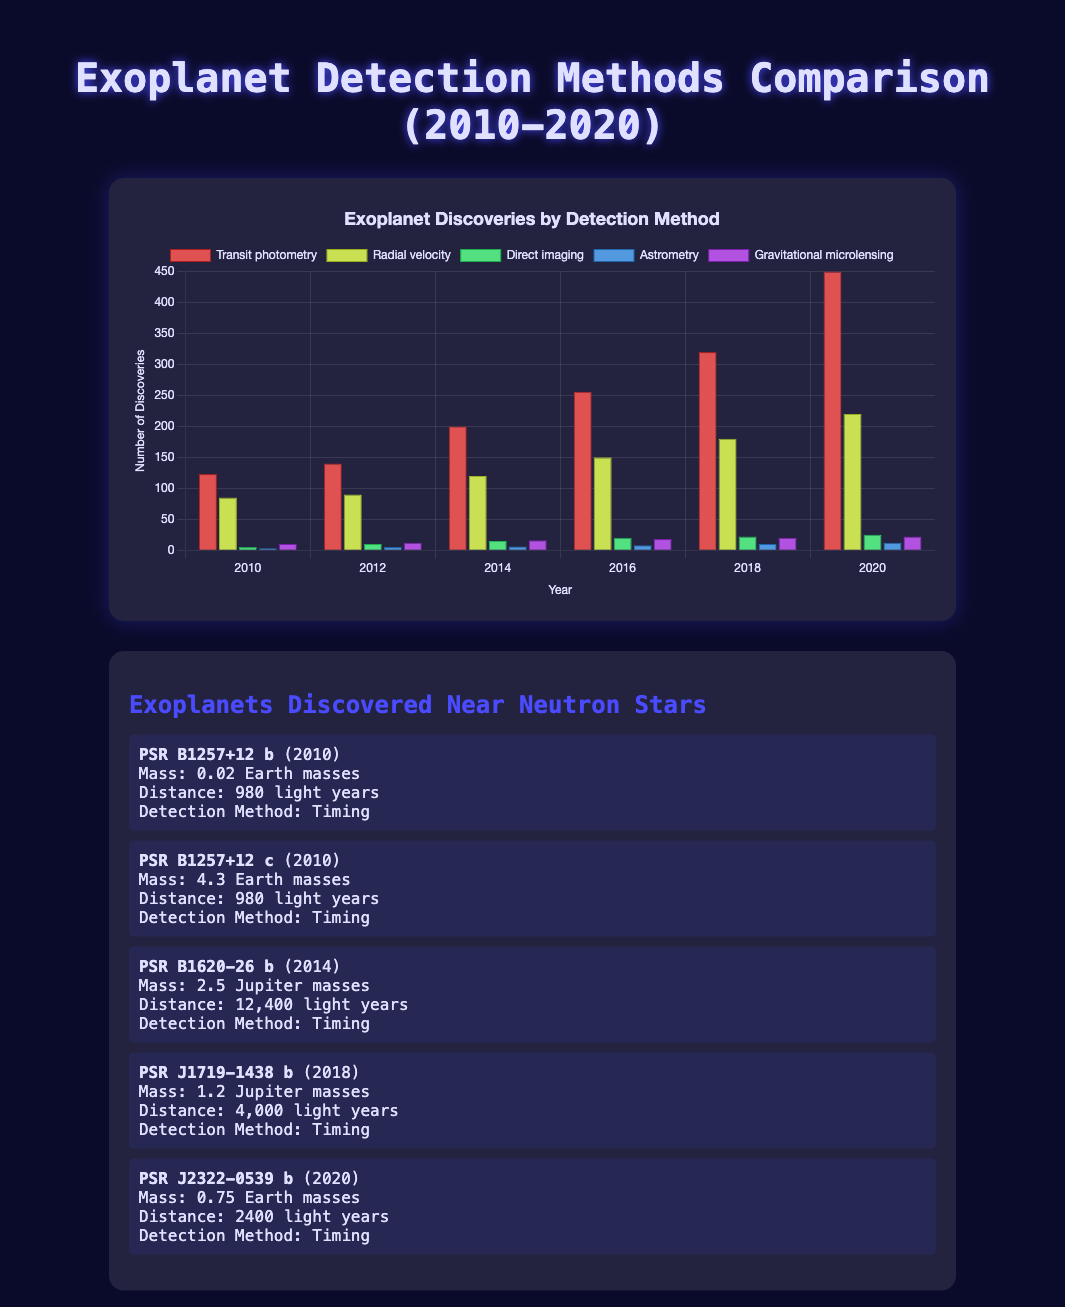Which exoplanet detection method had the most discoveries in 2010? To determine which detection method had the most discoveries in 2010, refer to the height of the bars in the chart for the year 2010. The bar representing Transit photometry is the highest.
Answer: Transit photometry How many exoplanets were discovered using Radial velocity in 2018 and 2020 combined? Check the number of Radial velocity discoveries in 2018 and 2020. In 2018, there were 180 discoveries, and in 2020, there were 220. Adding these together, 180 + 220 = 400.
Answer: 400 Which year had the highest number of total exoplanet discoveries across all methods? To find this, sum each method's discoveries for each year and compare them. For example, in 2020, there are 450 (Transit photometry) + 220 (Radial velocity) + 25 (Direct imaging) + 12 (Astrometry) + 22 (Gravitational microlensing) = 729, which is higher than any other year.
Answer: 2020 Which detection method has the least number of discoveries in 2012? Look at the bars corresponding to 2012 and identify the shortest one. The bar for Astrometry is the lowest at 5 discoveries.
Answer: Astrometry For which years between 2010 and 2020 were exoplanets discovered using the Timing method near Neutron Stars? The neutron star information reveals that exoplanets around neutron stars were discovered in the years 2010, 2014, 2018, and 2020.
Answer: 2010, 2014, 2018, 2020 What is the difference in the number of exoplanet discoveries between Transit photometry and Direct imaging in 2020? First, find the discovery numbers for both methods in 2020: 450 (Transit photometry) and 25 (Direct imaging). Then, subtract Direct imaging from Transit photometry: 450 - 25 = 425.
Answer: 425 What is the average number of exoplanet discoveries for Gravitational microlensing from 2010 to 2020? Sum the discoveries for Gravitational microlensing across all listed years (10 + 12 + 16 + 18 + 20 + 22) = 98, then divide by the number of years (6): 98 / 6 ≈ 16.33.
Answer: 16.33 Which detection method showed a steady increase in the number of discoveries from 2010 to 2020? By observing the trends, Transit photometry consistently shows increasing numbers of discoveries each year from 123 in 2010 to 450 in 2020.
Answer: Transit photometry What is the highest number of exoplanet discoveries for Astrometry between 2010 and 2020? Refer to the bars representing Astrometry and identify the peak value. The highest number of discoveries is 12, which occurred in 2020.
Answer: 12 